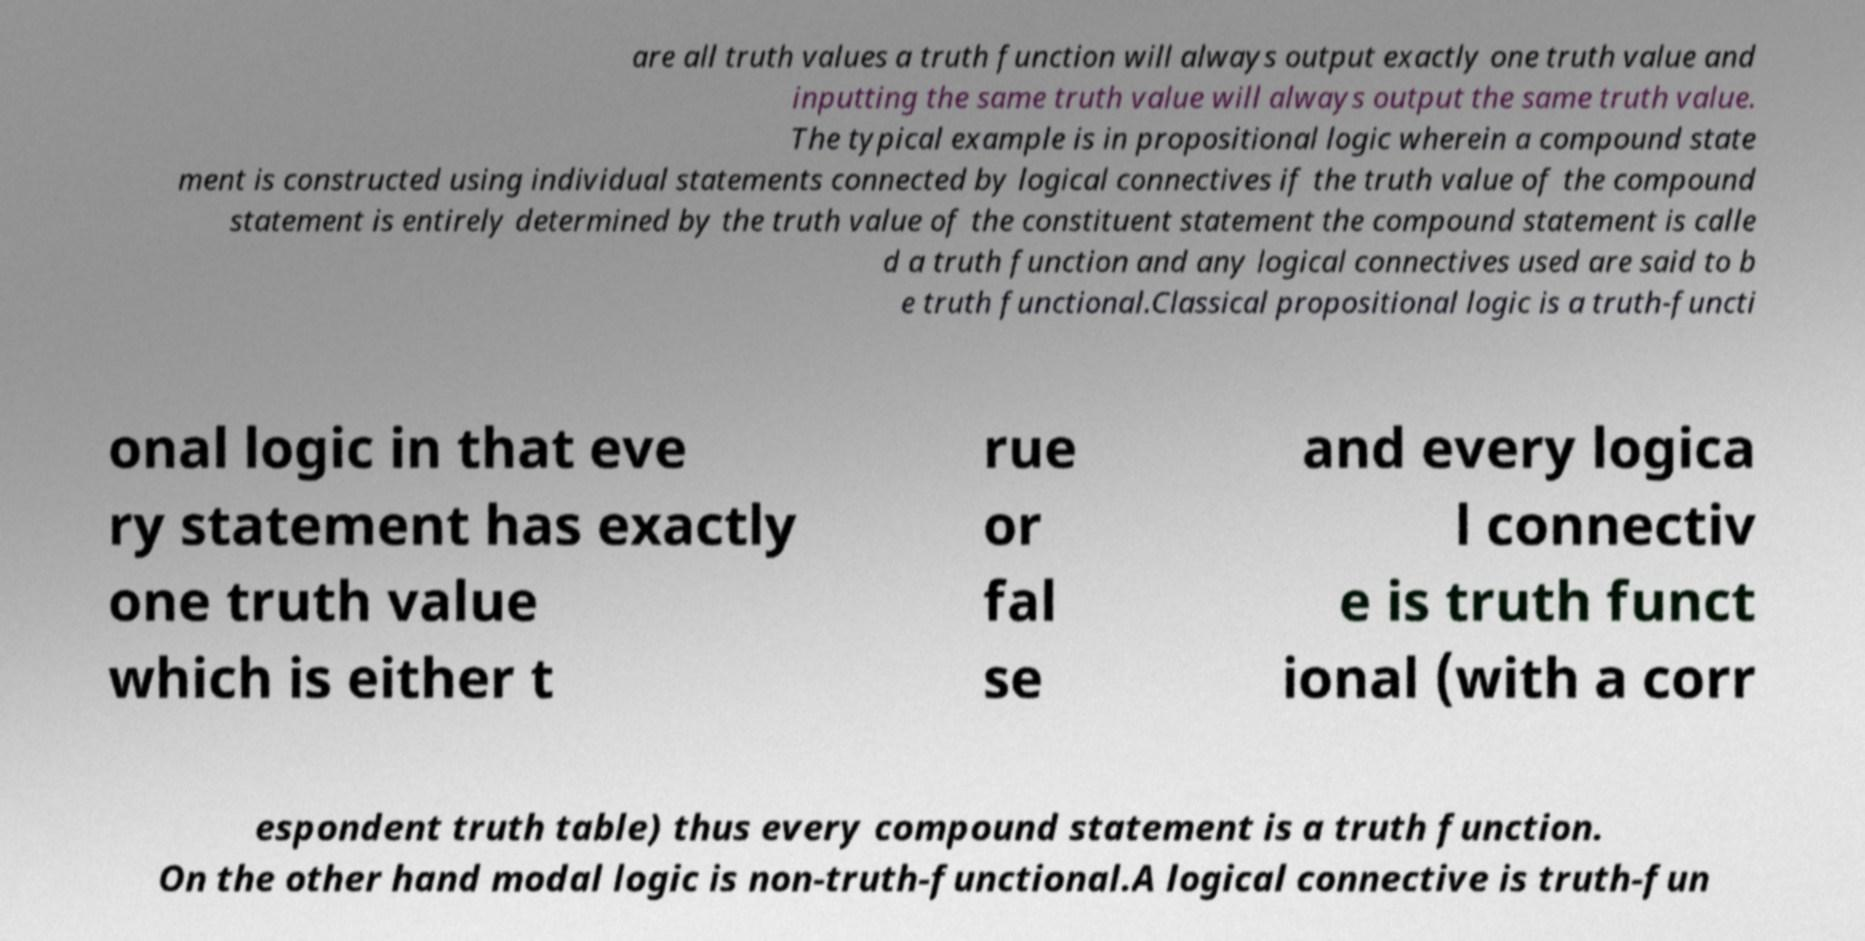There's text embedded in this image that I need extracted. Can you transcribe it verbatim? are all truth values a truth function will always output exactly one truth value and inputting the same truth value will always output the same truth value. The typical example is in propositional logic wherein a compound state ment is constructed using individual statements connected by logical connectives if the truth value of the compound statement is entirely determined by the truth value of the constituent statement the compound statement is calle d a truth function and any logical connectives used are said to b e truth functional.Classical propositional logic is a truth-functi onal logic in that eve ry statement has exactly one truth value which is either t rue or fal se and every logica l connectiv e is truth funct ional (with a corr espondent truth table) thus every compound statement is a truth function. On the other hand modal logic is non-truth-functional.A logical connective is truth-fun 